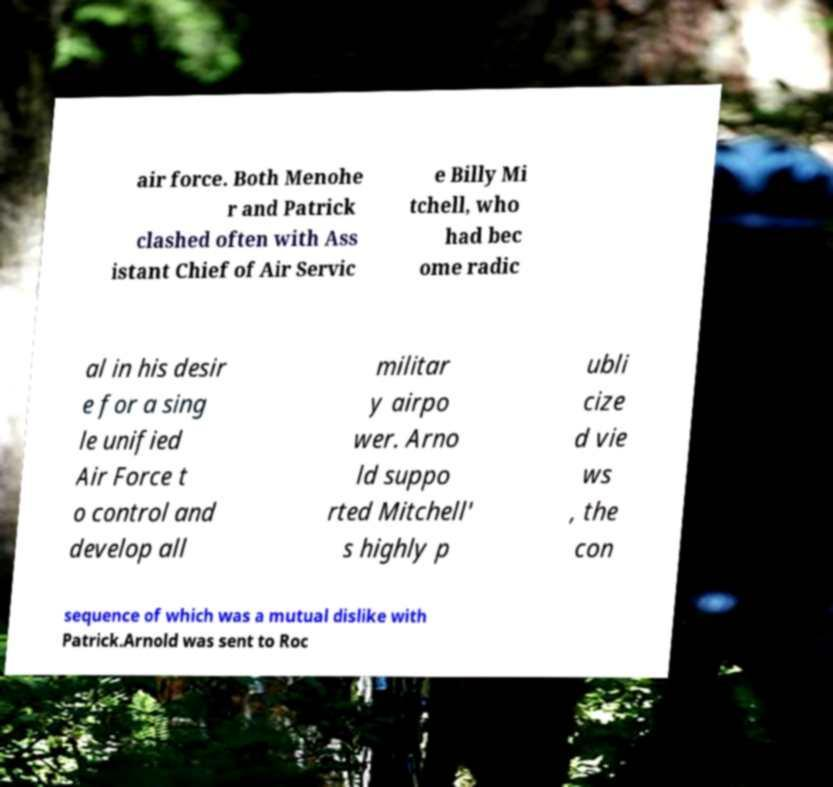There's text embedded in this image that I need extracted. Can you transcribe it verbatim? air force. Both Menohe r and Patrick clashed often with Ass istant Chief of Air Servic e Billy Mi tchell, who had bec ome radic al in his desir e for a sing le unified Air Force t o control and develop all militar y airpo wer. Arno ld suppo rted Mitchell' s highly p ubli cize d vie ws , the con sequence of which was a mutual dislike with Patrick.Arnold was sent to Roc 